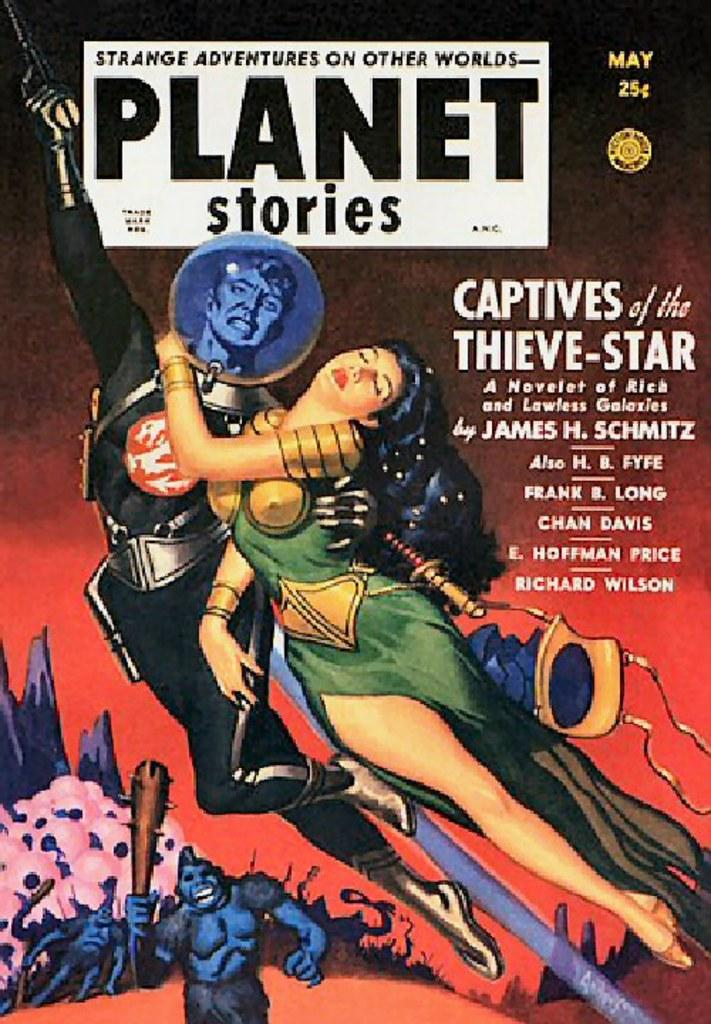Provide a one-sentence caption for the provided image. A magazine cover from may called Planet Stories. 